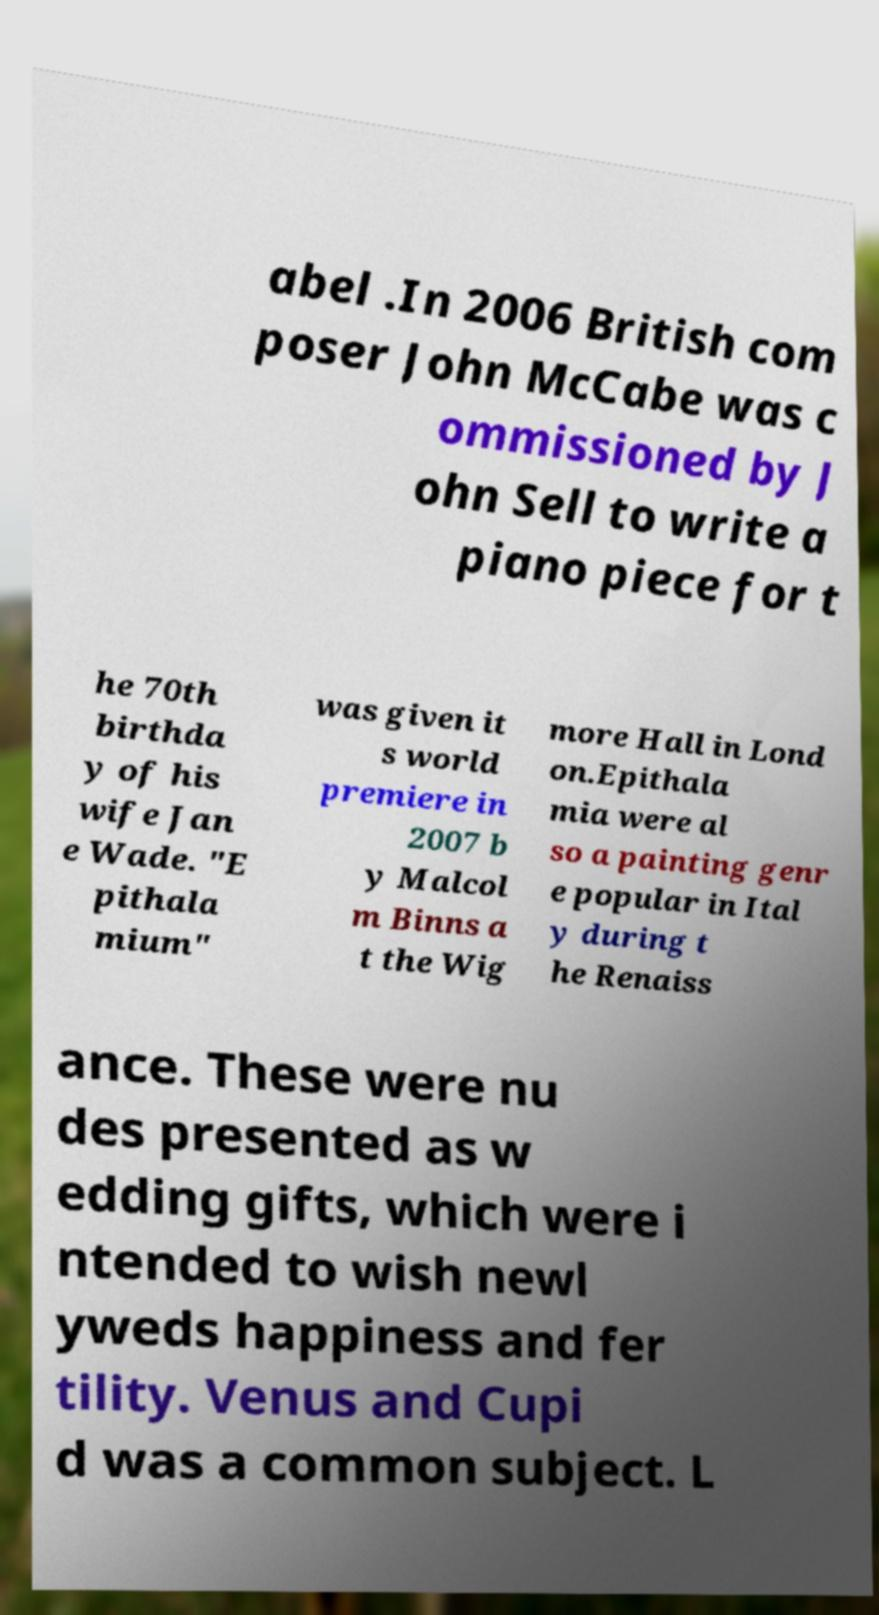I need the written content from this picture converted into text. Can you do that? abel .In 2006 British com poser John McCabe was c ommissioned by J ohn Sell to write a piano piece for t he 70th birthda y of his wife Jan e Wade. "E pithala mium" was given it s world premiere in 2007 b y Malcol m Binns a t the Wig more Hall in Lond on.Epithala mia were al so a painting genr e popular in Ital y during t he Renaiss ance. These were nu des presented as w edding gifts, which were i ntended to wish newl yweds happiness and fer tility. Venus and Cupi d was a common subject. L 